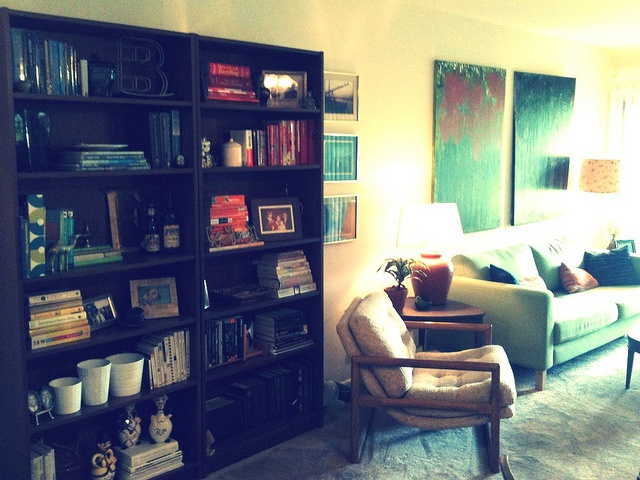Describe the objects in this image and their specific colors. I can see book in tan, navy, gray, and blue tones, couch in tan, ivory, teal, and blue tones, chair in tan, navy, gray, beige, and purple tones, book in tan, gray, and navy tones, and vase in tan, navy, purple, and beige tones in this image. 